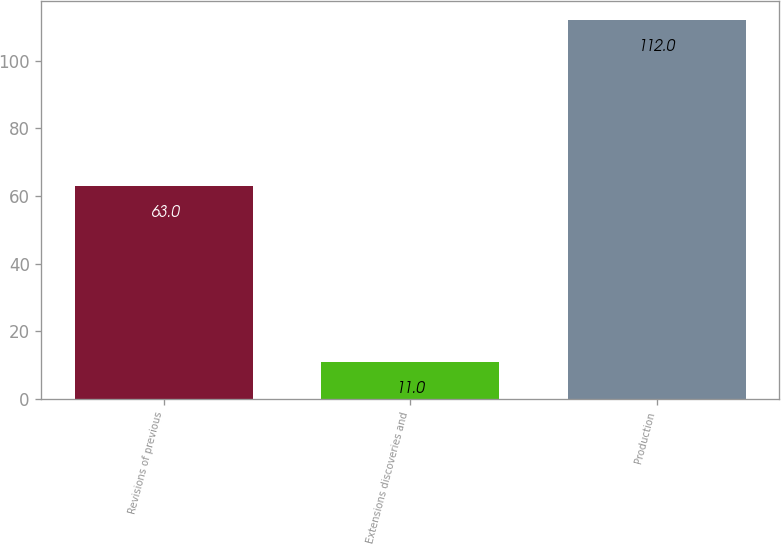Convert chart to OTSL. <chart><loc_0><loc_0><loc_500><loc_500><bar_chart><fcel>Revisions of previous<fcel>Extensions discoveries and<fcel>Production<nl><fcel>63<fcel>11<fcel>112<nl></chart> 